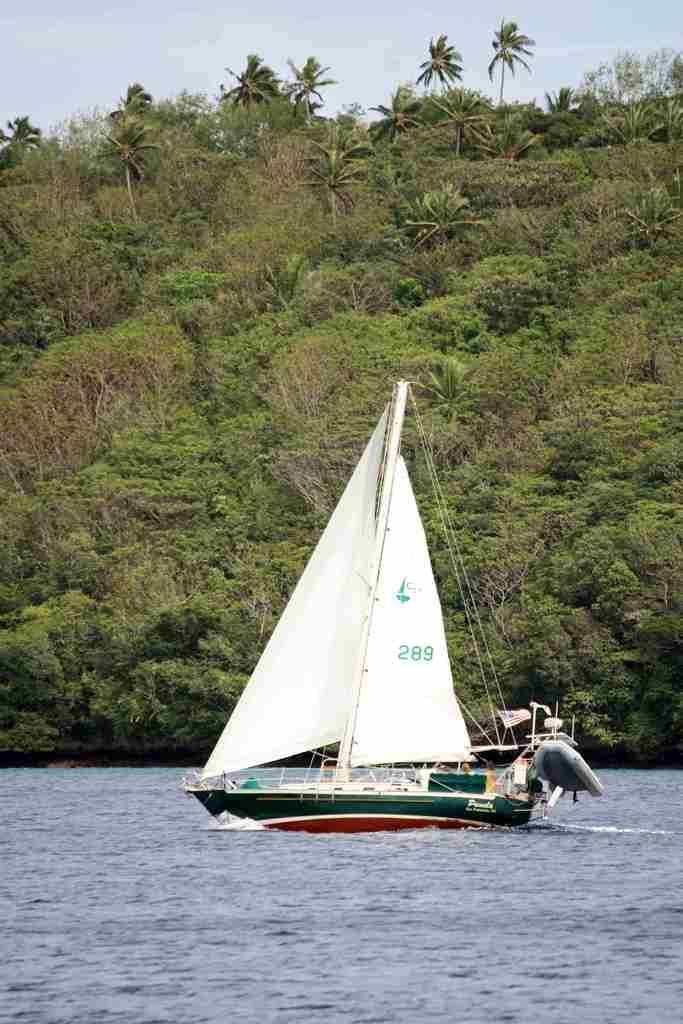Can you describe this image briefly? In this picture we can see a boat on the water and on the boat there is a pole and ropes. Behind the boat there are trees and the sky. 